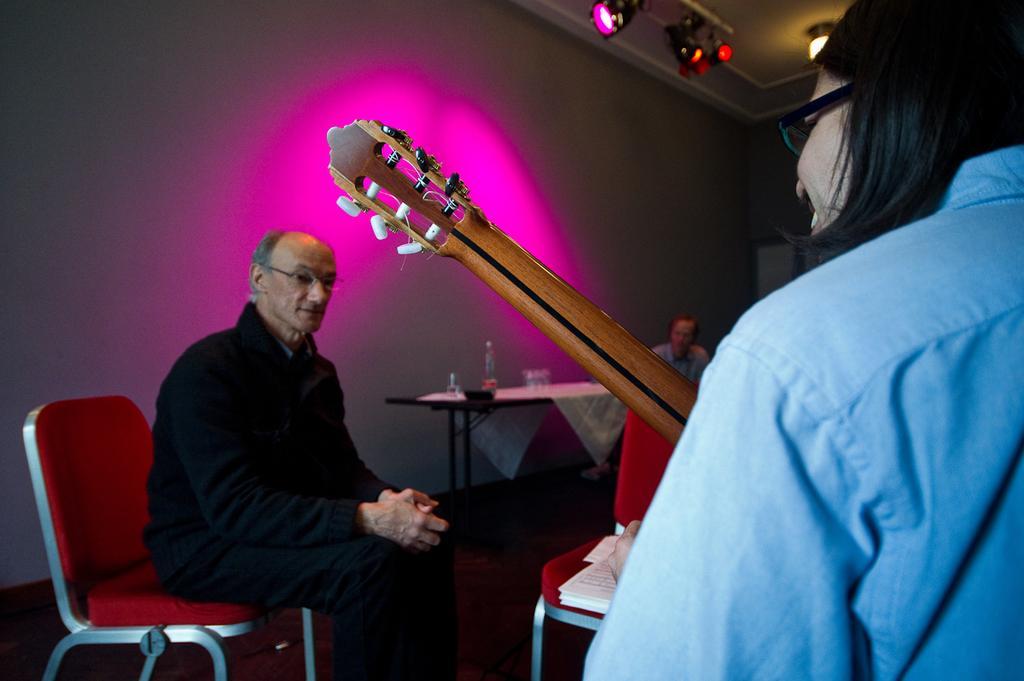Could you give a brief overview of what you see in this image? Here we can see a man is sitting on the chair, and in front here is the chair, and at back here is the table and some objects on it, and here is the wall. 